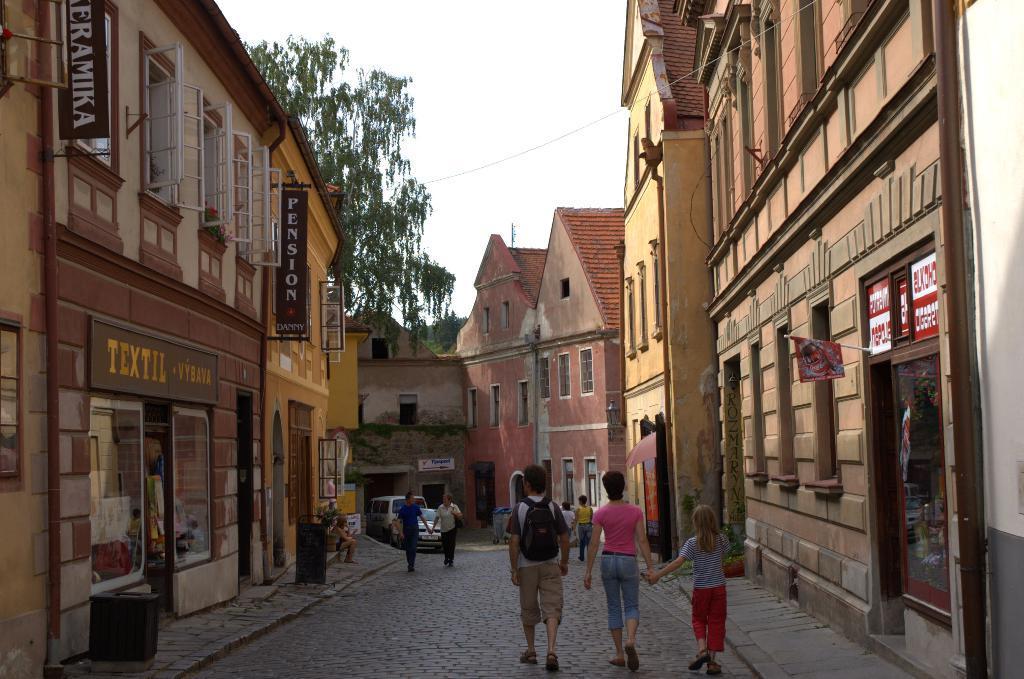Describe this image in one or two sentences. This picture is taken from the outside of the building. In this image, on the right side, we can see a building, glass door, window, flags and few posts attached to the window. In the middle of the image, we can see a group of people walking and few vehicles which are moving on the road. On the left side, we can see a building, glass door, window, hoardings, flower pot, plants and a person sitting. In the background, we can see some person sitting, window, trees, at the top, we can see a sky, at the bottom, we can see a footpath and a road. 